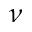<formula> <loc_0><loc_0><loc_500><loc_500>\nu</formula> 